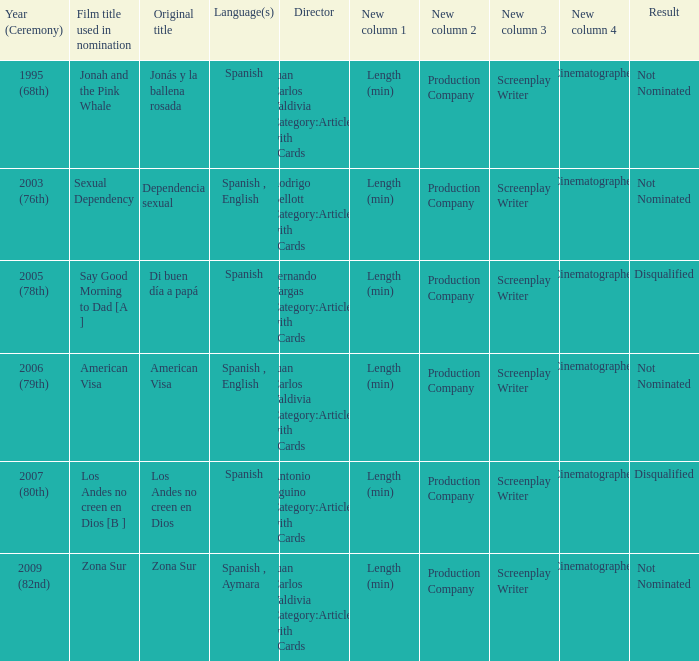What is Dependencia Sexual's film title that was used in its nomination? Sexual Dependency. 